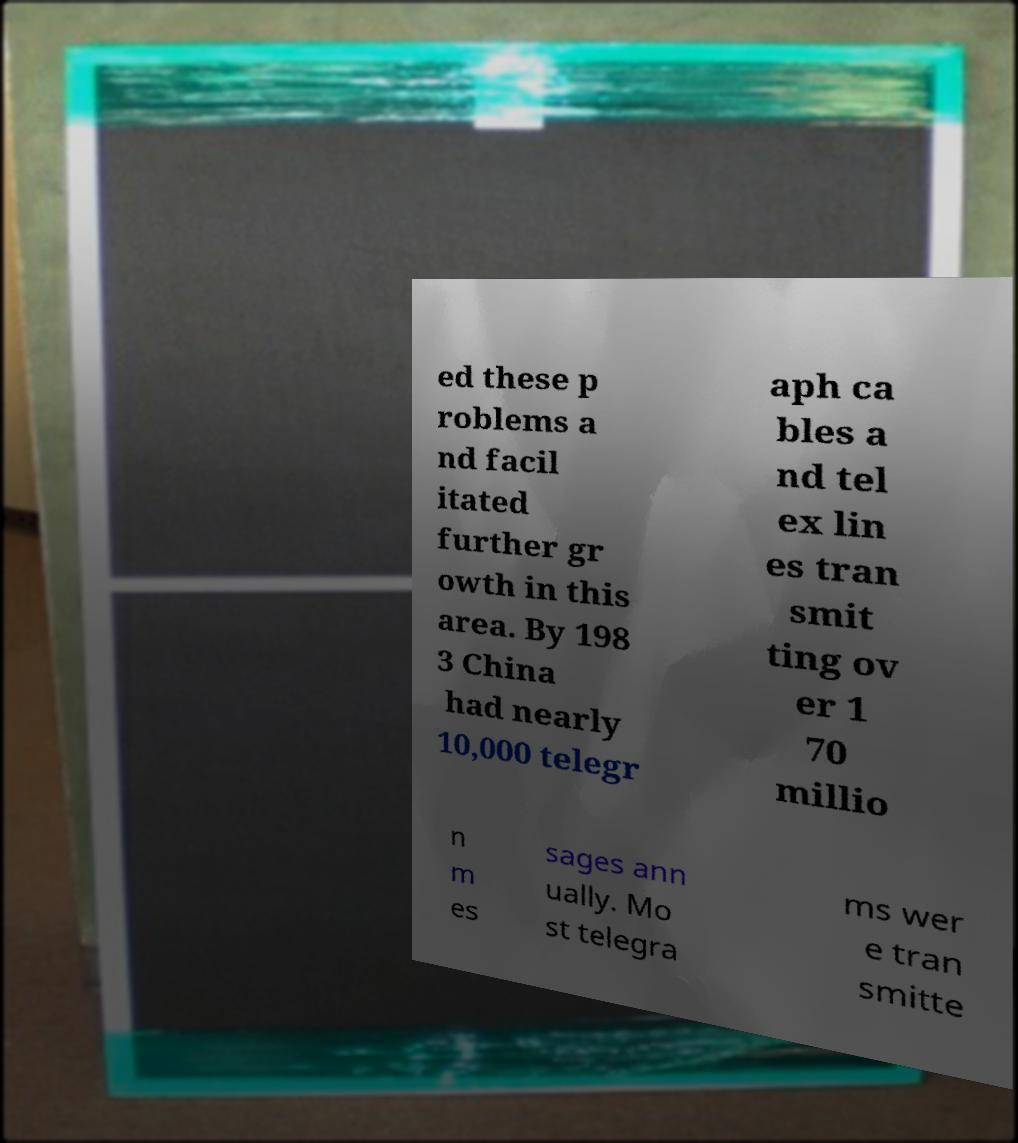Can you read and provide the text displayed in the image?This photo seems to have some interesting text. Can you extract and type it out for me? ed these p roblems a nd facil itated further gr owth in this area. By 198 3 China had nearly 10,000 telegr aph ca bles a nd tel ex lin es tran smit ting ov er 1 70 millio n m es sages ann ually. Mo st telegra ms wer e tran smitte 